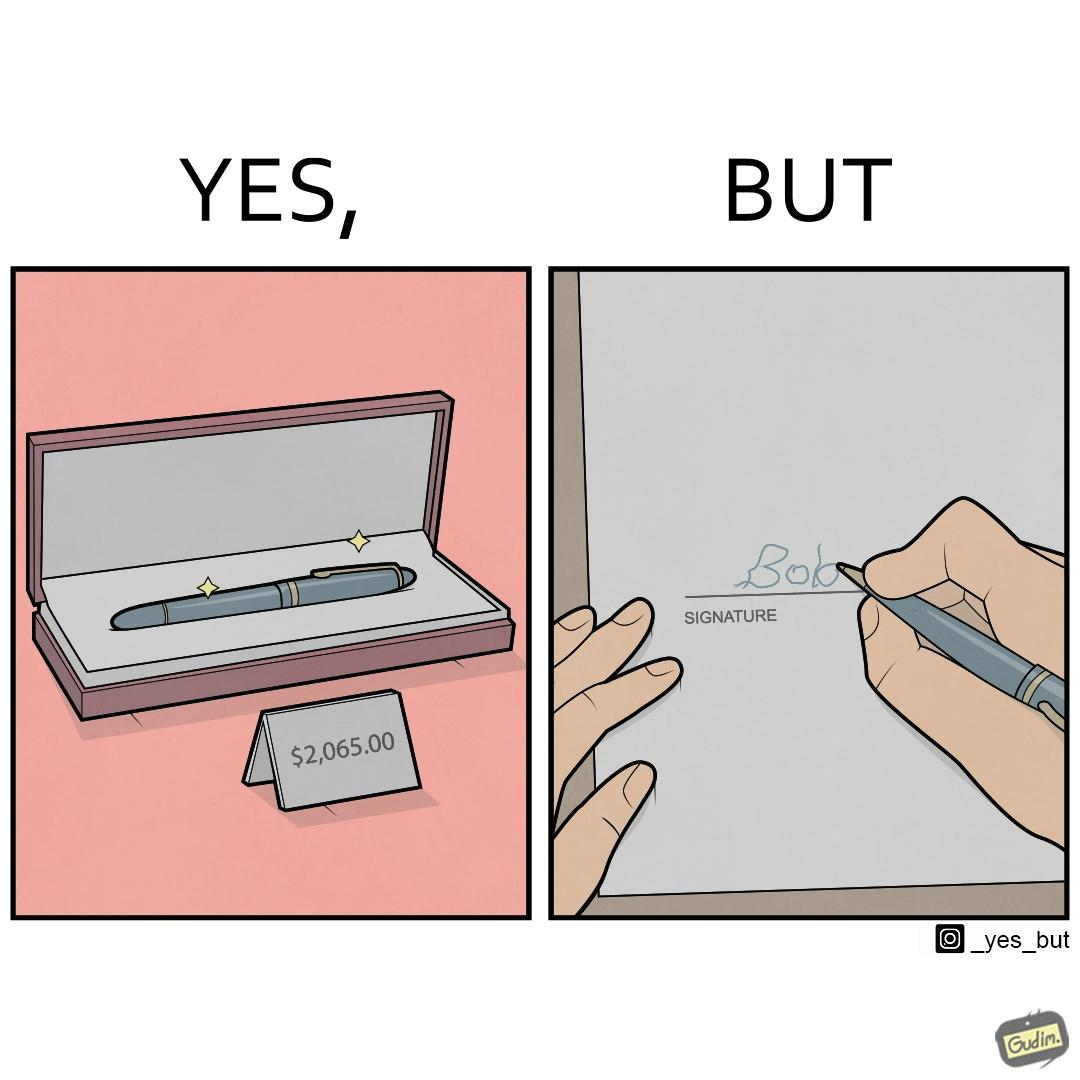Describe what you see in this image. The image is ironic, because it conveys the message that even with the costliest of pens people handwriting remains the same 